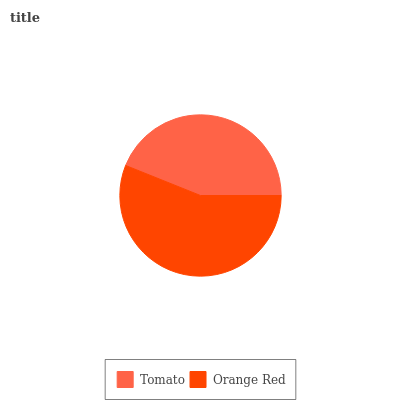Is Tomato the minimum?
Answer yes or no. Yes. Is Orange Red the maximum?
Answer yes or no. Yes. Is Orange Red the minimum?
Answer yes or no. No. Is Orange Red greater than Tomato?
Answer yes or no. Yes. Is Tomato less than Orange Red?
Answer yes or no. Yes. Is Tomato greater than Orange Red?
Answer yes or no. No. Is Orange Red less than Tomato?
Answer yes or no. No. Is Orange Red the high median?
Answer yes or no. Yes. Is Tomato the low median?
Answer yes or no. Yes. Is Tomato the high median?
Answer yes or no. No. Is Orange Red the low median?
Answer yes or no. No. 